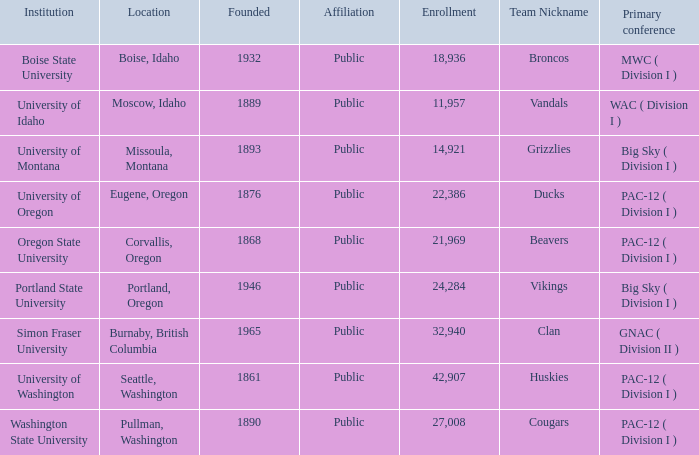What is the site of the team called broncos, formed following 1889? Boise, Idaho. 